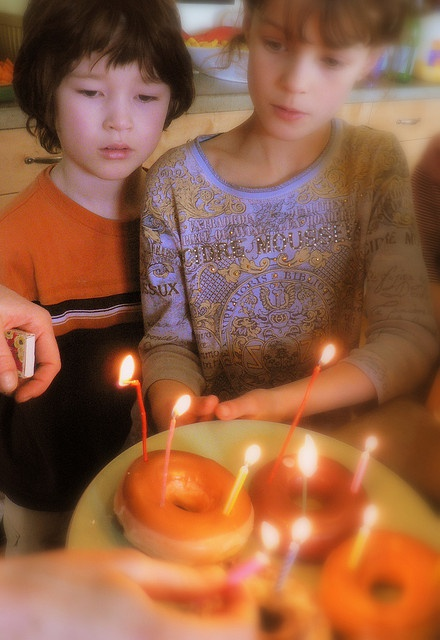Describe the objects in this image and their specific colors. I can see people in olive, maroon, gray, and brown tones, people in olive, black, brown, gray, and maroon tones, donut in olive, red, brown, orange, and maroon tones, donut in olive, red, orange, and brown tones, and donut in olive, red, brown, and salmon tones in this image. 